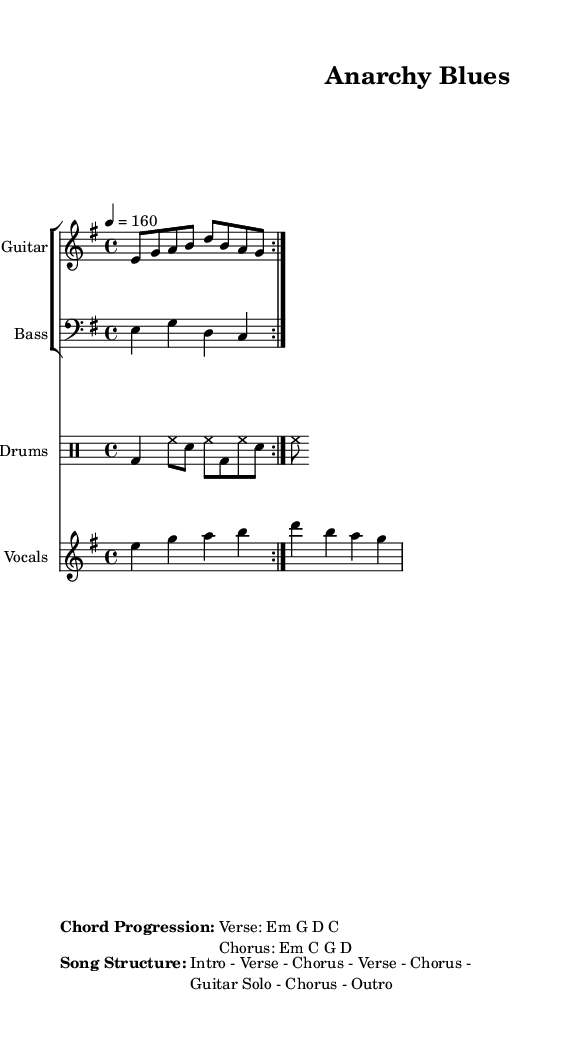What is the key signature of this music? The key signature is E minor, which has one sharp (F#). The indication for the key is found at the beginning of the score, showing the notes and the corresponding sharps or flats.
Answer: E minor What is the time signature of the piece? The time signature is 4/4, as indicated at the beginning of the score. This means there are four beats in a measure and the quarter note receives one beat.
Answer: 4/4 What is the tempo marking for this piece? The tempo marking is 160 beats per minute, denoted as "4 = 160." This shows the speed at which the music should be played.
Answer: 160 What are the chord progressions for the verse? The chord progression for the verse is E minor, G, D, C, which is detailed in the marked section of the score. This specifies the harmonies played during the verse.
Answer: Em G D C In what order does the song structure progress? The song structure progresses in the order: Intro, Verse, Chorus, Verse, Chorus, Guitar Solo, Chorus, Outro. This sequence provides the overall layout of the song as noted in the score.
Answer: Intro - Verse - Chorus - Verse - Chorus - Guitar Solo - Chorus - Outro What instruments are indicated in the score? The instruments indicated in the score are Guitar, Bass, Drums, and Vocals. Each part of the score is labeled with the specific instrument name for clarity.
Answer: Guitar, Bass, Drums, Vocals 